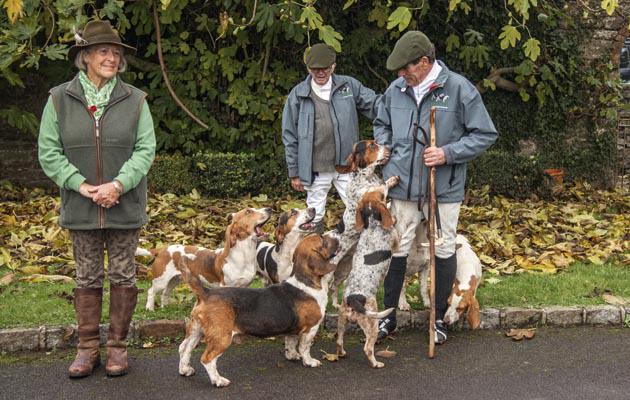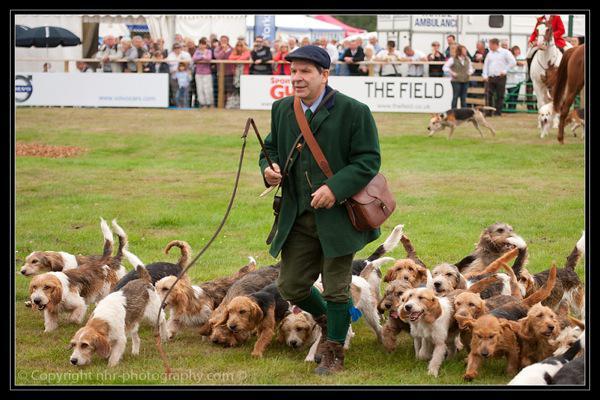The first image is the image on the left, the second image is the image on the right. Assess this claim about the two images: "In one of the images there are at least two people surrounded by a group of hunting dogs.". Correct or not? Answer yes or no. Yes. The first image is the image on the left, the second image is the image on the right. Analyze the images presented: Is the assertion "An image shows a person in a green jacket holding a whip and walking leftward with a pack of dogs." valid? Answer yes or no. Yes. 